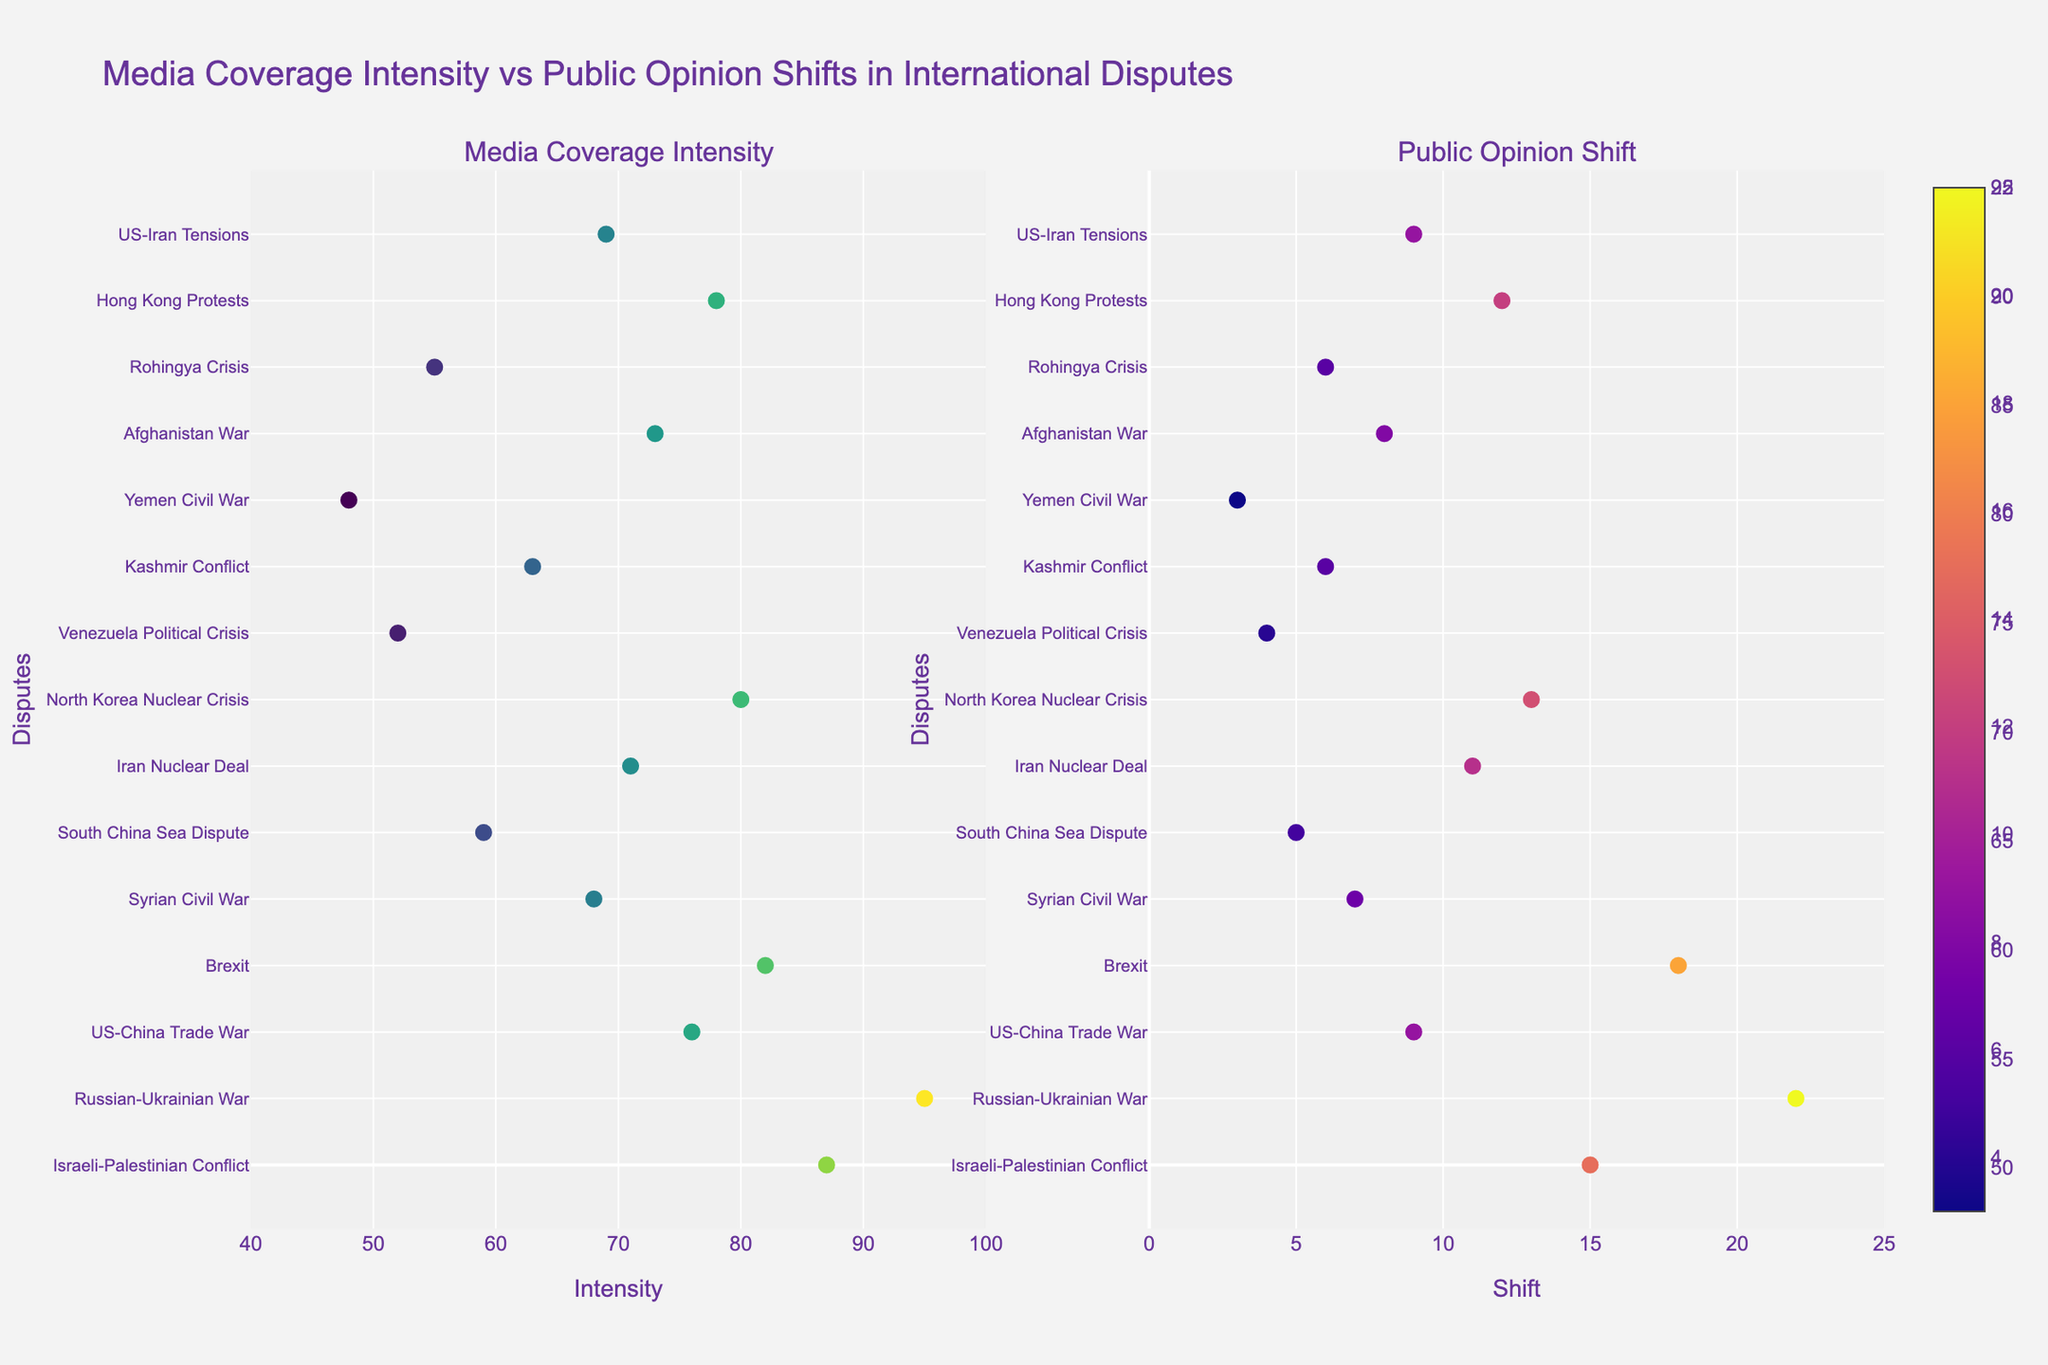What is the title of the figure? The title is located at the top of the figure and gives a summary of what the figure represents. In this case, the title is "Most-Cited Scientific Papers in the Last Decade".
Answer: Most-Cited Scientific Papers in the Last Decade How many fields are represented in the top subplot? The top subplot includes bars that correspond to different fields. By counting these bars, we can determine the number of fields represented.
Answer: 10 Which scientific paper is the most cited? The second subplot lists paper titles and their respective citations. The bar with the highest citations represents the most-cited paper. The title "Deep Learning in Neural Networks: An Overview" has the highest citation of 11234.
Answer: Deep Learning in Neural Networks: An Overview How many citations does the "CRISPR-Cas9: A Revolutionary Genome Editing Tool" paper have? This paper title appears in the second subplot, where bars represent citation counts. We can read the value associated with this bar, which is 9876.
Answer: 9876 Which field has the second-highest citation count? In the top subplot, compare the heights of the bars to identify the second highest. The bar corresponding to "Physics" is slightly lower than "Computer Science," indicating 10234 citations.
Answer: Physics What is the total number of citations for papers in Physics and Chemistry combined? Find the number of citations for Physics (10234) and Chemistry (8765) from the top subplot, then sum them: 10234 + 8765 = 18999.
Answer: 18999 What is the difference in citations between "The Cancer Genome Atlas" and "Global Warming of 1.5°C" papers? Subtract the number of citations for "Global Warming of 1.5°C" (8901) from "The Cancer Genome Atlas" (9543): 9543 - 8901 = 642.
Answer: 642 Which paper has more citations: "Graphene: The Wonder Material of the 21st Century" or "The Brain's Default Mode Network: Anatomy and Function"? Compare the citation counts from the second subplot. "Graphene" has 9123 citations, while "The Brain's Default Mode Network" has 8432 citations. Therefore, "Graphene" has more.
Answer: Graphene: The Wonder Material of the 21st Century Are there any fields with exactly the same number of citations? Look for bars of the same height in the top subplot. Physics and Astronomy both have 8765 citations.
Answer: Yes, Physics and Astronomy 